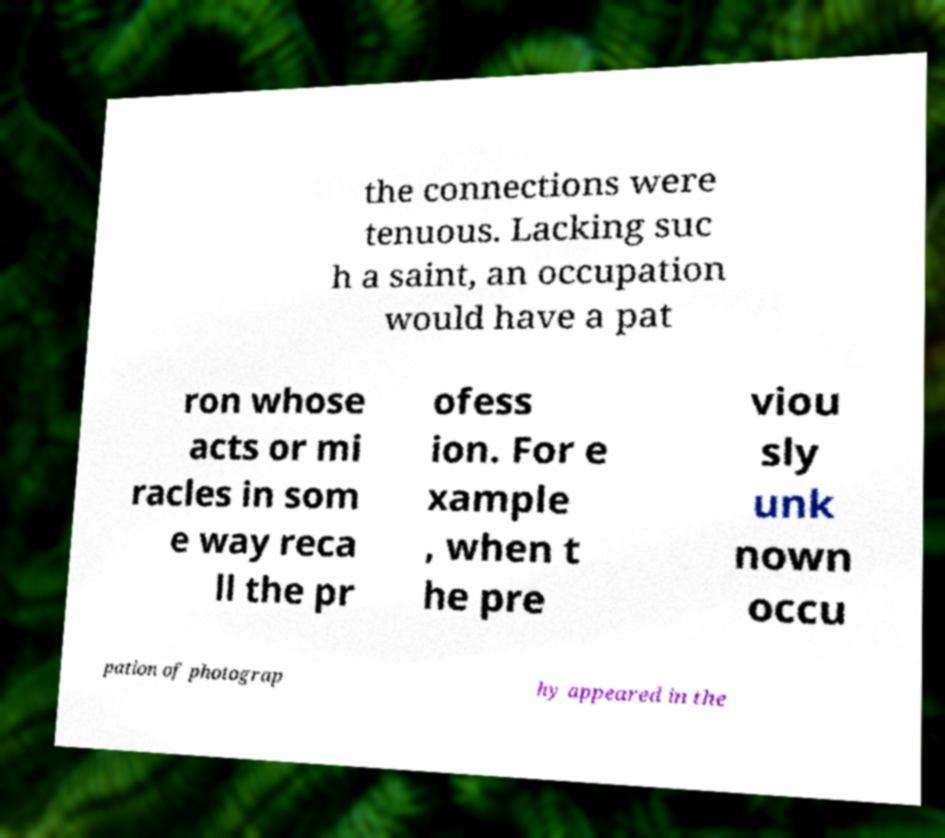Can you read and provide the text displayed in the image?This photo seems to have some interesting text. Can you extract and type it out for me? the connections were tenuous. Lacking suc h a saint, an occupation would have a pat ron whose acts or mi racles in som e way reca ll the pr ofess ion. For e xample , when t he pre viou sly unk nown occu pation of photograp hy appeared in the 